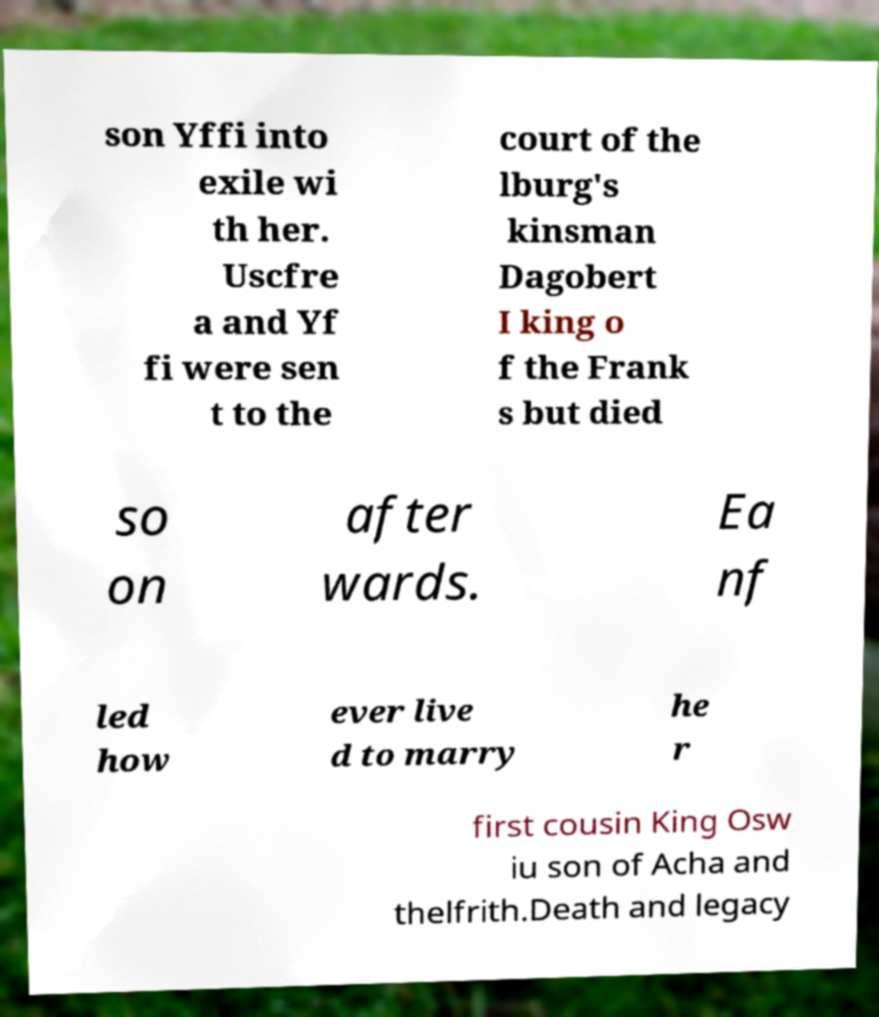There's text embedded in this image that I need extracted. Can you transcribe it verbatim? son Yffi into exile wi th her. Uscfre a and Yf fi were sen t to the court of the lburg's kinsman Dagobert I king o f the Frank s but died so on after wards. Ea nf led how ever live d to marry he r first cousin King Osw iu son of Acha and thelfrith.Death and legacy 